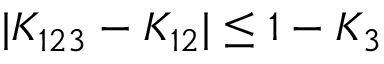<formula> <loc_0><loc_0><loc_500><loc_500>| K _ { 1 2 3 } - K _ { 1 2 } | \leq 1 - K _ { 3 }</formula> 